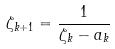<formula> <loc_0><loc_0><loc_500><loc_500>\zeta _ { k + 1 } = \frac { 1 } { \zeta _ { k } - a _ { k } }</formula> 